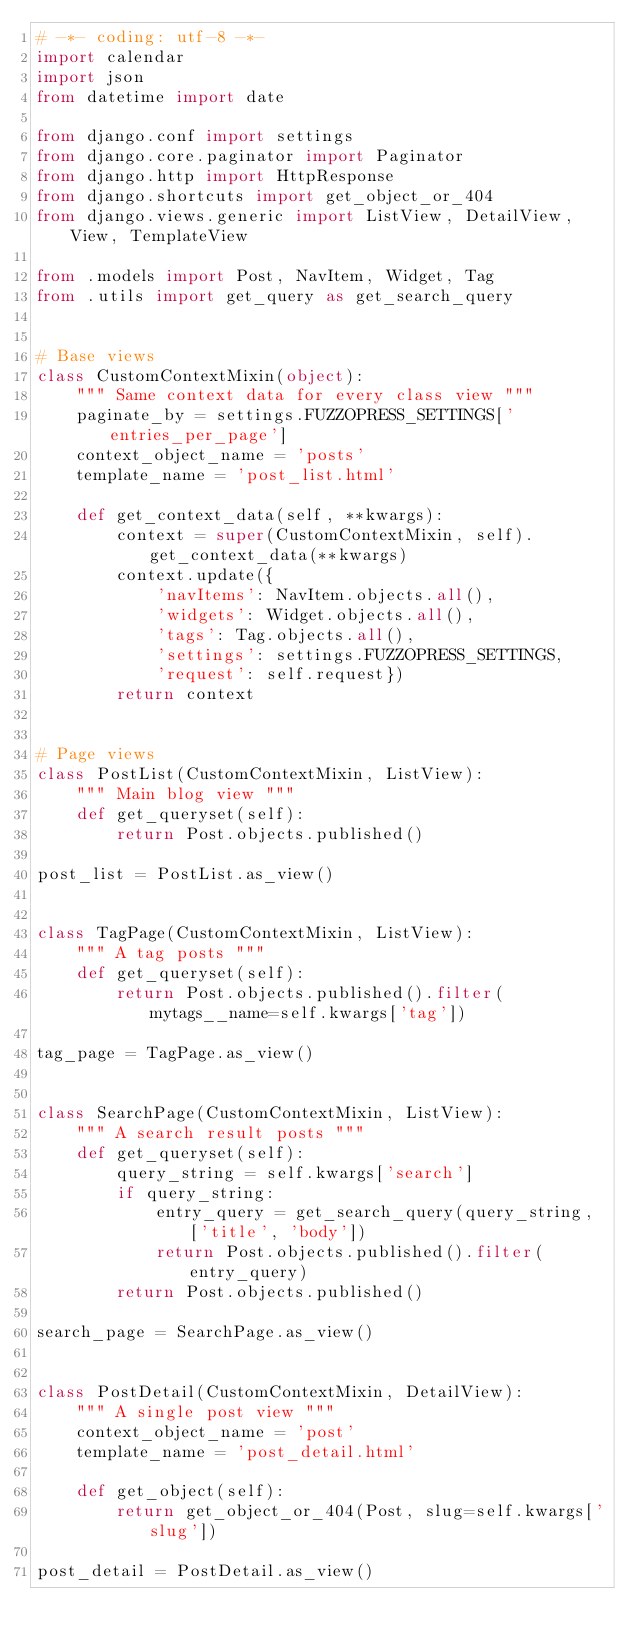Convert code to text. <code><loc_0><loc_0><loc_500><loc_500><_Python_># -*- coding: utf-8 -*-
import calendar
import json
from datetime import date

from django.conf import settings
from django.core.paginator import Paginator
from django.http import HttpResponse
from django.shortcuts import get_object_or_404
from django.views.generic import ListView, DetailView, View, TemplateView

from .models import Post, NavItem, Widget, Tag
from .utils import get_query as get_search_query


# Base views
class CustomContextMixin(object):
    """ Same context data for every class view """
    paginate_by = settings.FUZZOPRESS_SETTINGS['entries_per_page']
    context_object_name = 'posts'
    template_name = 'post_list.html'

    def get_context_data(self, **kwargs):
        context = super(CustomContextMixin, self).get_context_data(**kwargs)
        context.update({
            'navItems': NavItem.objects.all(),
            'widgets': Widget.objects.all(),
            'tags': Tag.objects.all(),
            'settings': settings.FUZZOPRESS_SETTINGS,
            'request': self.request})
        return context


# Page views
class PostList(CustomContextMixin, ListView):
    """ Main blog view """
    def get_queryset(self):
        return Post.objects.published()

post_list = PostList.as_view()


class TagPage(CustomContextMixin, ListView):
    """ A tag posts """
    def get_queryset(self):
        return Post.objects.published().filter(mytags__name=self.kwargs['tag'])

tag_page = TagPage.as_view()


class SearchPage(CustomContextMixin, ListView):
    """ A search result posts """
    def get_queryset(self):
        query_string = self.kwargs['search']
        if query_string:
            entry_query = get_search_query(query_string, ['title', 'body'])
            return Post.objects.published().filter(entry_query)
        return Post.objects.published()

search_page = SearchPage.as_view()


class PostDetail(CustomContextMixin, DetailView):
    """ A single post view """
    context_object_name = 'post'
    template_name = 'post_detail.html'

    def get_object(self):
        return get_object_or_404(Post, slug=self.kwargs['slug'])

post_detail = PostDetail.as_view()

</code> 